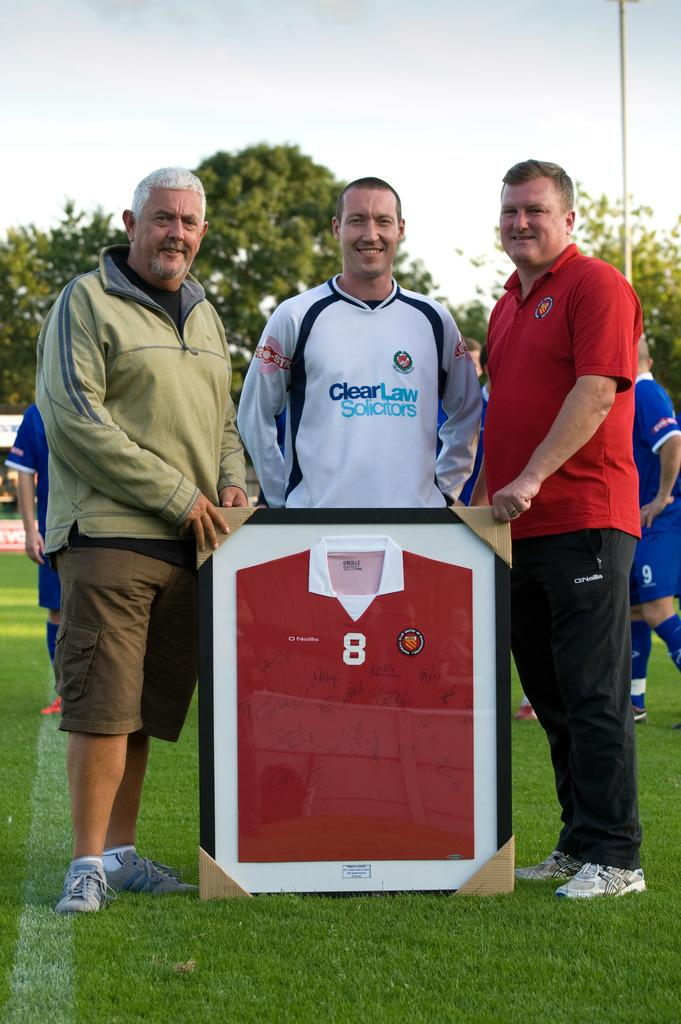<image>
Present a compact description of the photo's key features. A young man's shirt says Clear Law Solicitors on the front. 